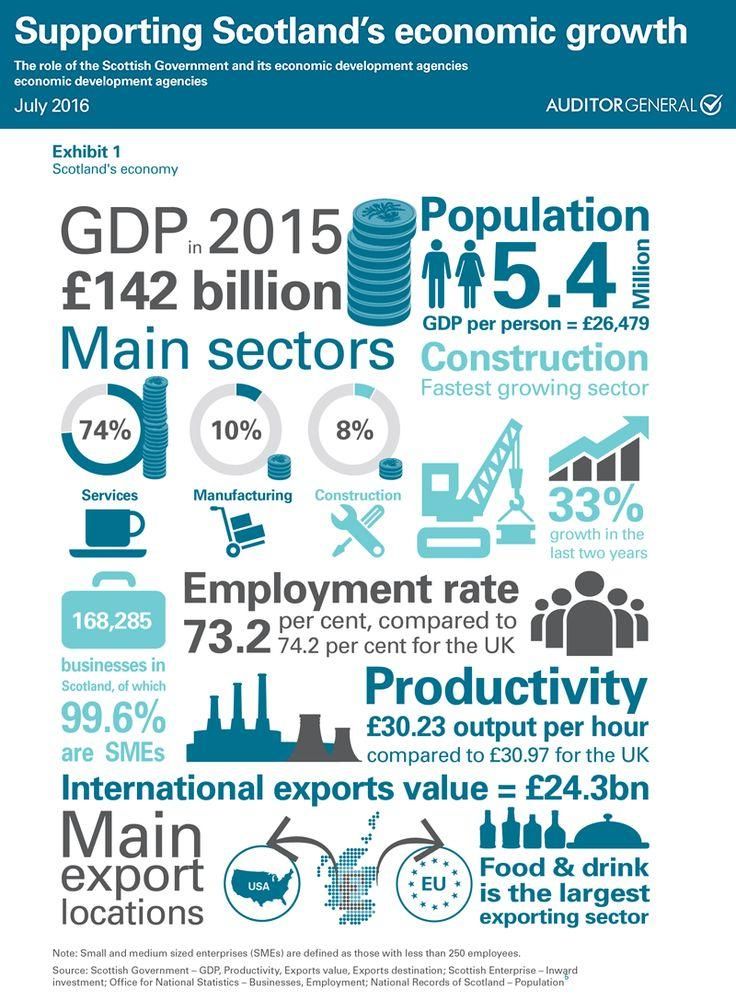Indicate a few pertinent items in this graphic. There are two main export locations. According to the data, the construction sector experienced a growth of 33% in the given period. The services sector is the sector that makes the greatest contribution to a nation's Gross Domestic Product (GDP). There are 168,285 businesses mentioned in Scotland. 